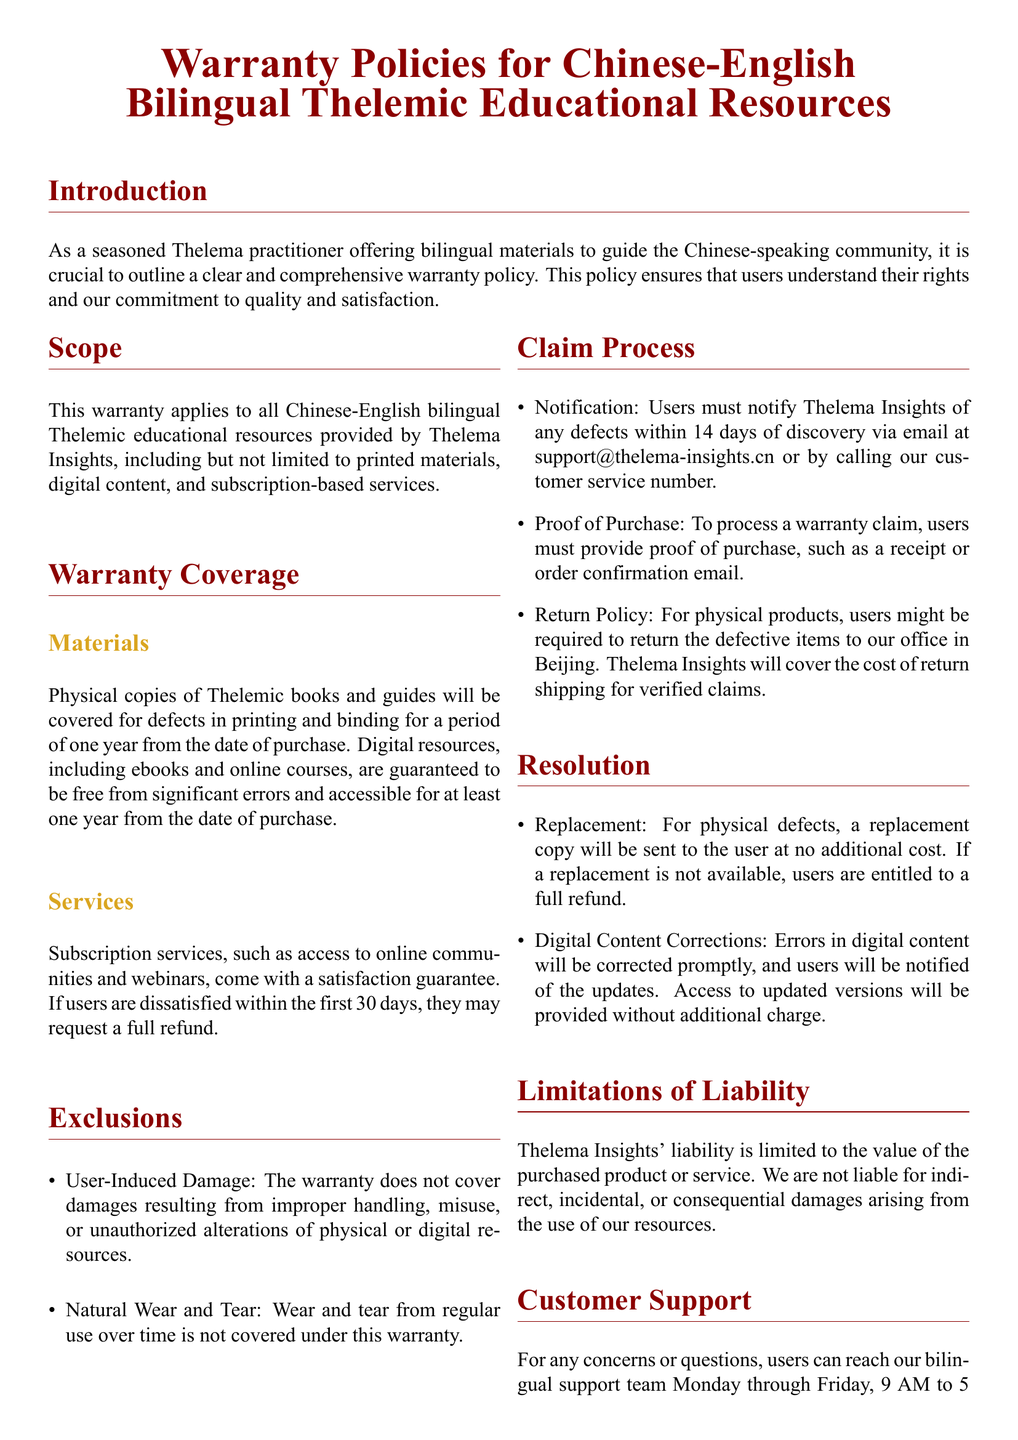What is the duration of warranty coverage for physical copies? The document states that physical copies of Thelemic books and guides will be covered for a period of one year from the date of purchase.
Answer: One year What should users provide to process a warranty claim? To process a warranty claim, the document specifies that users must provide proof of purchase, such as a receipt or order confirmation email.
Answer: Proof of purchase What is the email address for customer support? The document lists the email address for customer support as support@thelema-insights.cn.
Answer: support@thelema-insights.cn How long do users have to notify about defects? Users must notify Thelema Insights of any defects within 14 days of discovery according to the warranty policy.
Answer: 14 days What will happen if a replacement is not available? If a replacement is not available, the users are entitled to a full refund.
Answer: Full refund What is the contact number for customer service? The customer service number provided in the document is +86 10 1234 5678.
Answer: +86 10 1234 5678 What is the satisfaction guarantee period for subscription services? The document mentions that subscription services come with a satisfaction guarantee period of 30 days.
Answer: 30 days Are digital resources guaranteed against significant errors? Yes, the document guarantees that digital resources, including ebooks and online courses, are to be free from significant errors.
Answer: Yes 